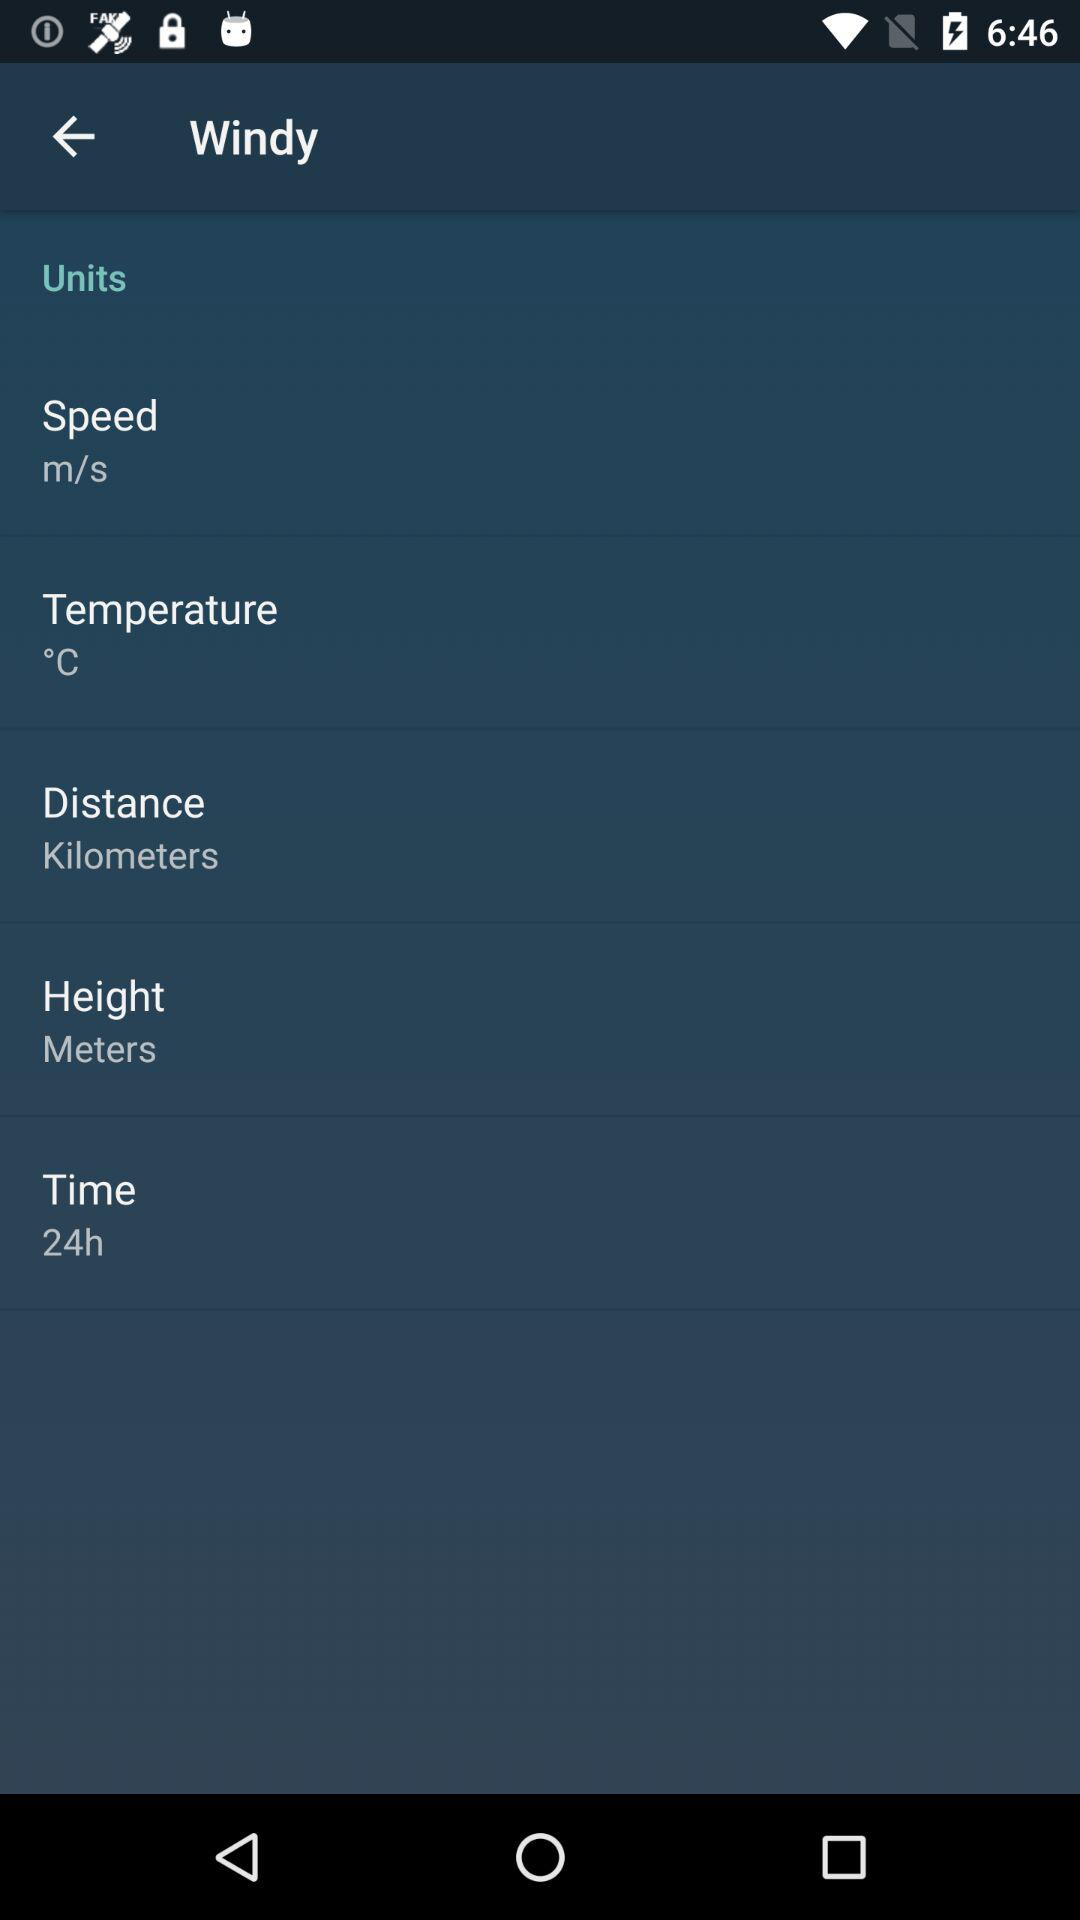How many units are available?
Answer the question using a single word or phrase. 5 